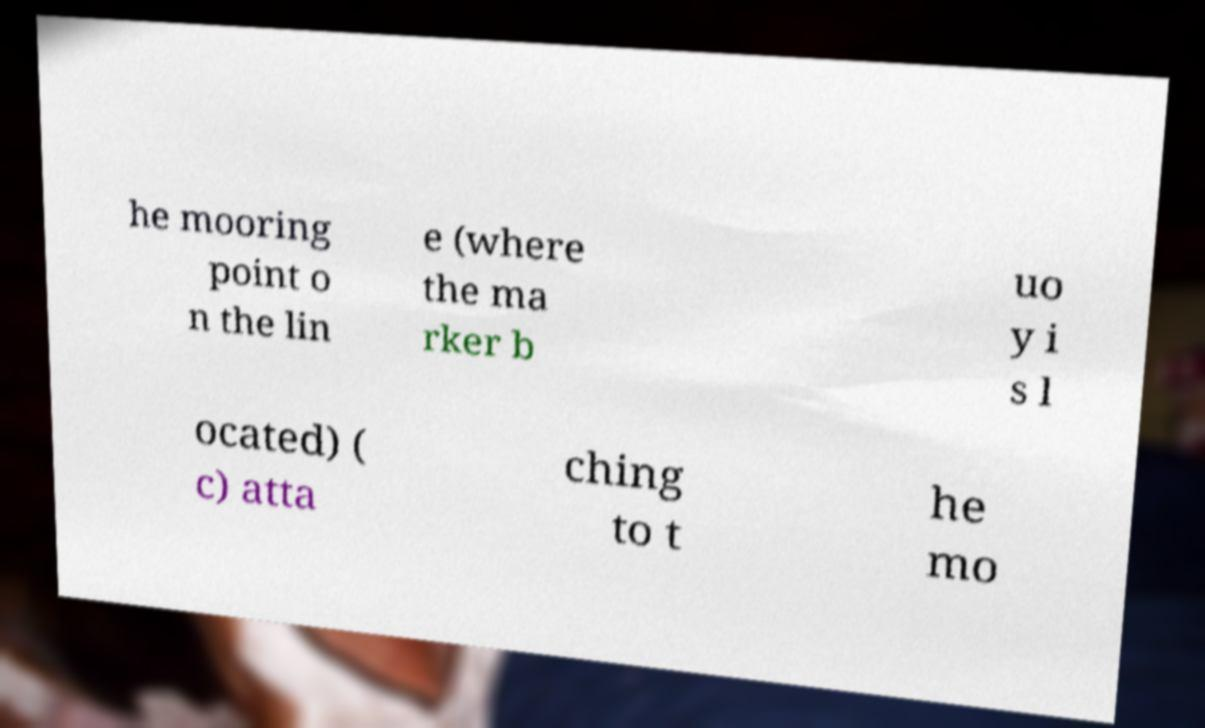For documentation purposes, I need the text within this image transcribed. Could you provide that? he mooring point o n the lin e (where the ma rker b uo y i s l ocated) ( c) atta ching to t he mo 